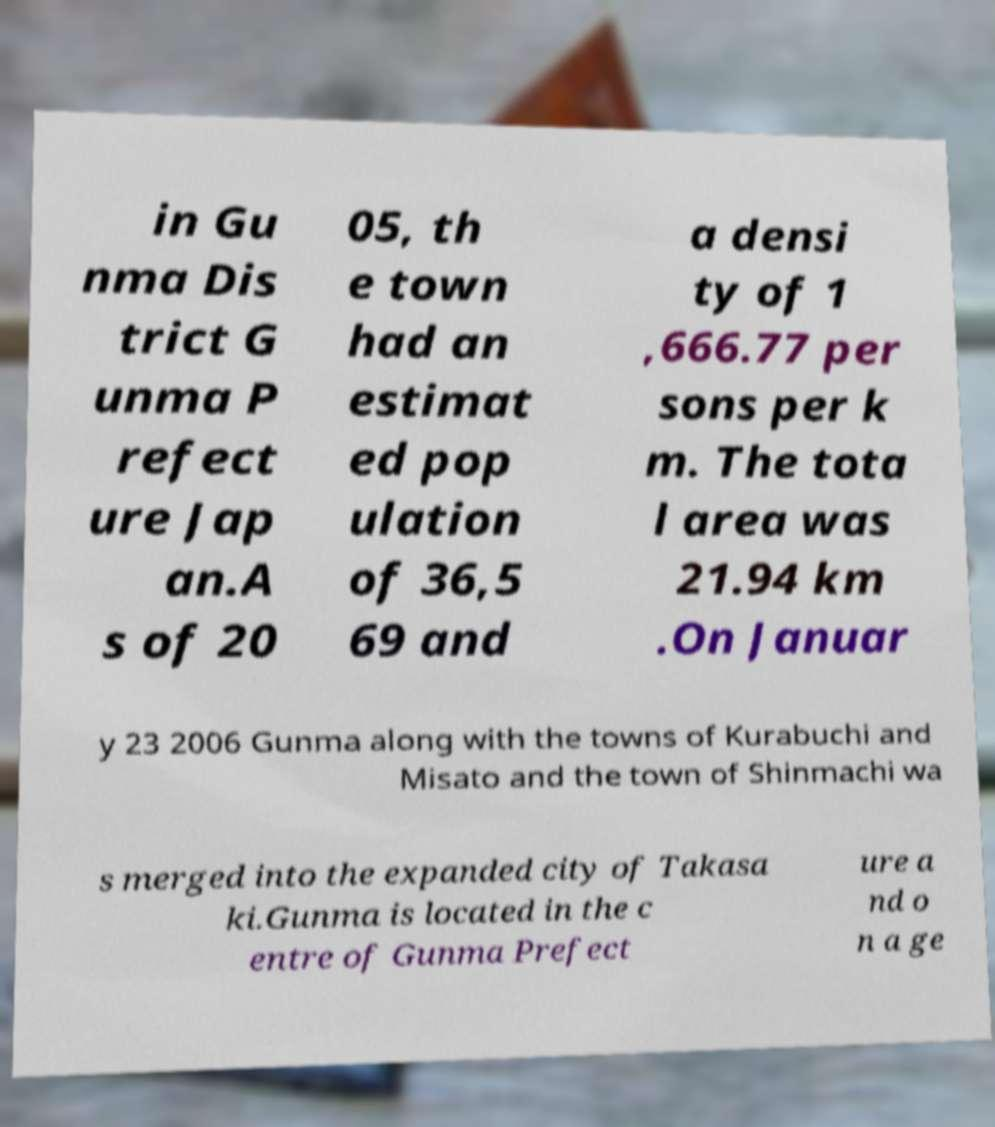Can you read and provide the text displayed in the image?This photo seems to have some interesting text. Can you extract and type it out for me? in Gu nma Dis trict G unma P refect ure Jap an.A s of 20 05, th e town had an estimat ed pop ulation of 36,5 69 and a densi ty of 1 ,666.77 per sons per k m. The tota l area was 21.94 km .On Januar y 23 2006 Gunma along with the towns of Kurabuchi and Misato and the town of Shinmachi wa s merged into the expanded city of Takasa ki.Gunma is located in the c entre of Gunma Prefect ure a nd o n a ge 